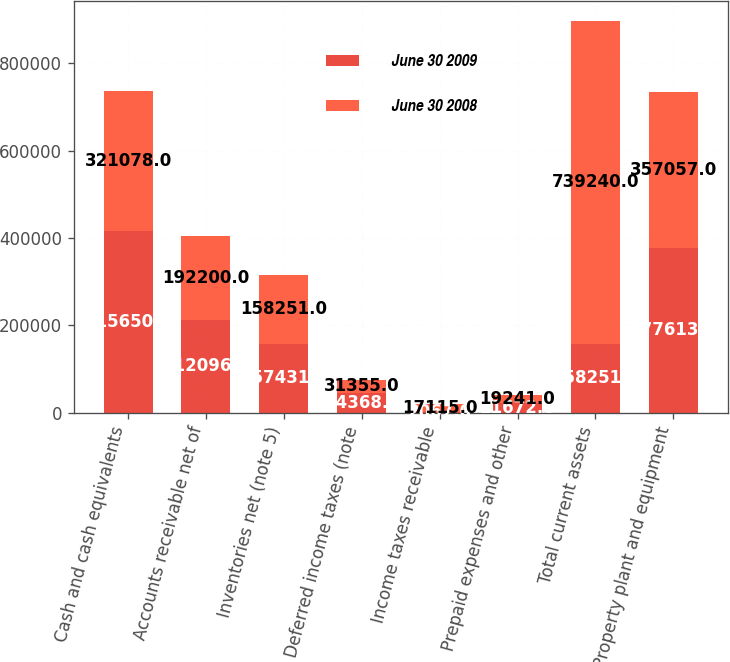Convert chart to OTSL. <chart><loc_0><loc_0><loc_500><loc_500><stacked_bar_chart><ecel><fcel>Cash and cash equivalents<fcel>Accounts receivable net of<fcel>Inventories net (note 5)<fcel>Deferred income taxes (note<fcel>Income taxes receivable<fcel>Prepaid expenses and other<fcel>Total current assets<fcel>Property plant and equipment<nl><fcel>June 30 2009<fcel>415650<fcel>212096<fcel>157431<fcel>44368<fcel>2067<fcel>21672<fcel>158251<fcel>377613<nl><fcel>June 30 2008<fcel>321078<fcel>192200<fcel>158251<fcel>31355<fcel>17115<fcel>19241<fcel>739240<fcel>357057<nl></chart> 